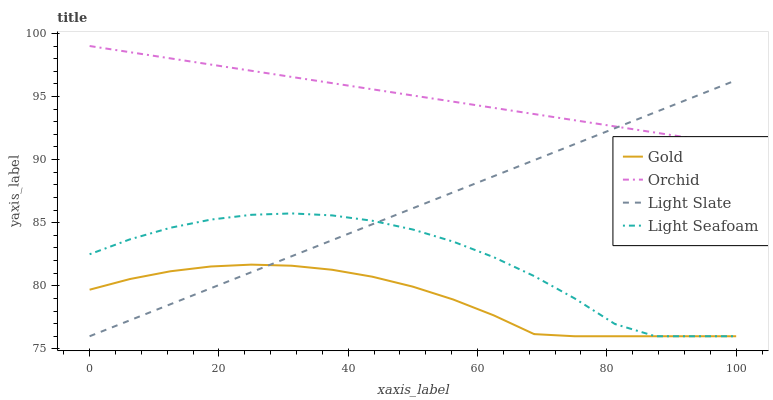Does Light Seafoam have the minimum area under the curve?
Answer yes or no. No. Does Light Seafoam have the maximum area under the curve?
Answer yes or no. No. Is Gold the smoothest?
Answer yes or no. No. Is Gold the roughest?
Answer yes or no. No. Does Orchid have the lowest value?
Answer yes or no. No. Does Light Seafoam have the highest value?
Answer yes or no. No. Is Gold less than Orchid?
Answer yes or no. Yes. Is Orchid greater than Gold?
Answer yes or no. Yes. Does Gold intersect Orchid?
Answer yes or no. No. 